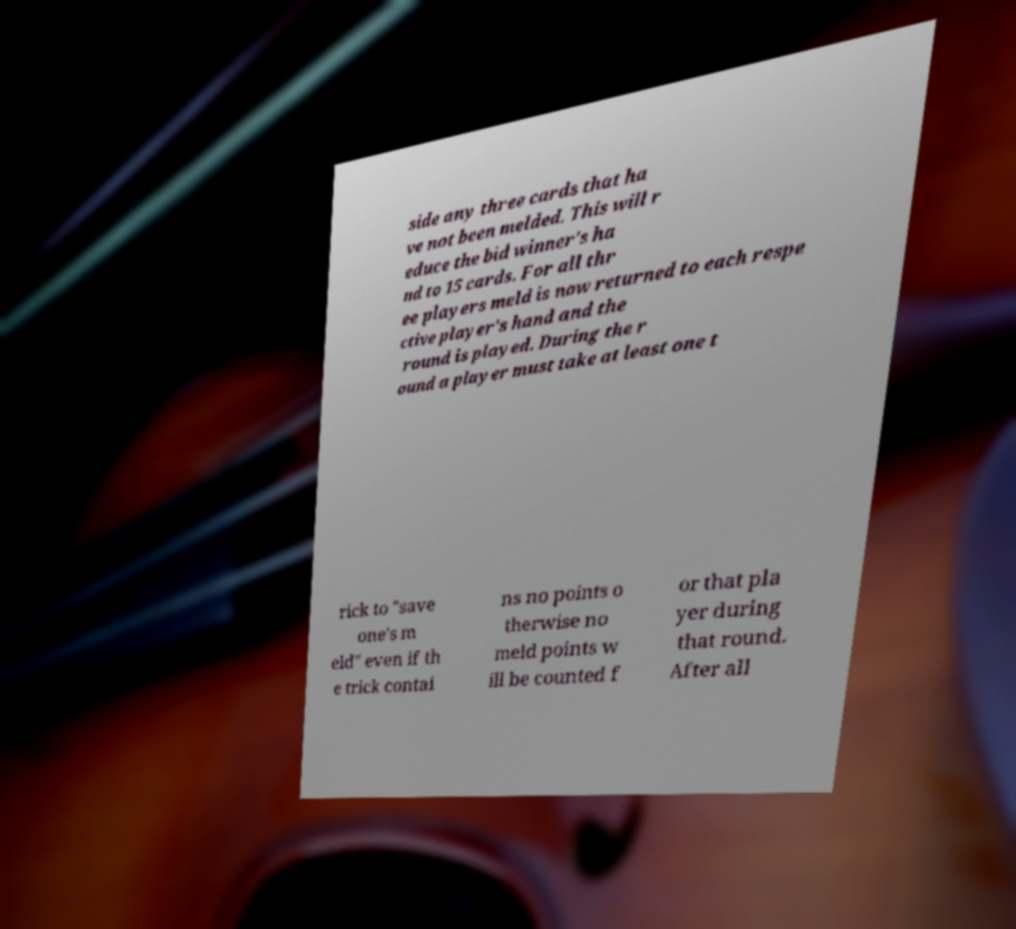Can you read and provide the text displayed in the image?This photo seems to have some interesting text. Can you extract and type it out for me? side any three cards that ha ve not been melded. This will r educe the bid winner's ha nd to 15 cards. For all thr ee players meld is now returned to each respe ctive player's hand and the round is played. During the r ound a player must take at least one t rick to "save one's m eld" even if th e trick contai ns no points o therwise no meld points w ill be counted f or that pla yer during that round. After all 